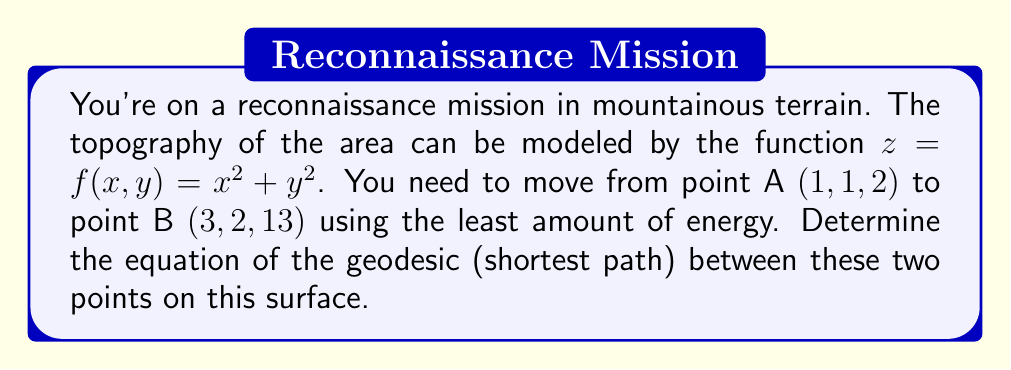Show me your answer to this math problem. To find the geodesic (shortest path) between two points on a surface, we need to use the Euler-Lagrange equations from calculus of variations. Here's the step-by-step process:

1) First, we parameterize the curve as $(x(t), y(t), z(t))$ where $t$ is the parameter.

2) The arc length element is given by:
   $$ds = \sqrt{(dx)^2 + (dy)^2 + (dz)^2}$$

3) Substituting $z = x^2 + y^2$, we get:
   $$ds = \sqrt{(dx)^2 + (dy)^2 + (2xdx + 2ydy)^2}$$

4) The arc length functional is:
   $$L = \int_{t_1}^{t_2} \sqrt{(1+4x^2)(\frac{dx}{dt})^2 + (1+4y^2)(\frac{dy}{dt})^2 + 8xy\frac{dx}{dt}\frac{dy}{dt}} dt$$

5) Let $F(x,y,x',y') = \sqrt{(1+4x^2)(x')^2 + (1+4y^2)(y')^2 + 8xyx'y'}$

6) The Euler-Lagrange equations are:
   $$\frac{\partial F}{\partial x} - \frac{d}{dt}\frac{\partial F}{\partial x'} = 0$$
   $$\frac{\partial F}{\partial y} - \frac{d}{dt}\frac{\partial F}{\partial y'} = 0$$

7) Solving these equations leads to a system of differential equations. The general solution to this system is:
   $$x(t) = c_1 \cos(t) + c_2 \sin(t) + c_3$$
   $$y(t) = c_4 \cos(t) + c_5 \sin(t) + c_6$$

8) Using the boundary conditions:
   At $t=0$: $(x,y,z) = (1,1,2)$
   At $t=T$: $(x,y,z) = (3,2,13)$

9) Solving for the constants gives us the specific solution:
   $$x(t) = 1 + 2\cos(\frac{\pi}{2} - t)$$
   $$y(t) = 1 + \sin(\frac{\pi}{2} - t)$$

This is the equation of the geodesic in parametric form.
Answer: $x(t) = 1 + 2\cos(\frac{\pi}{2} - t)$, $y(t) = 1 + \sin(\frac{\pi}{2} - t)$ 